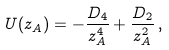Convert formula to latex. <formula><loc_0><loc_0><loc_500><loc_500>U ( z _ { A } ) = - \frac { D _ { 4 } } { z _ { A } ^ { 4 } } + \frac { D _ { 2 } } { z _ { A } ^ { 2 } } \, ,</formula> 